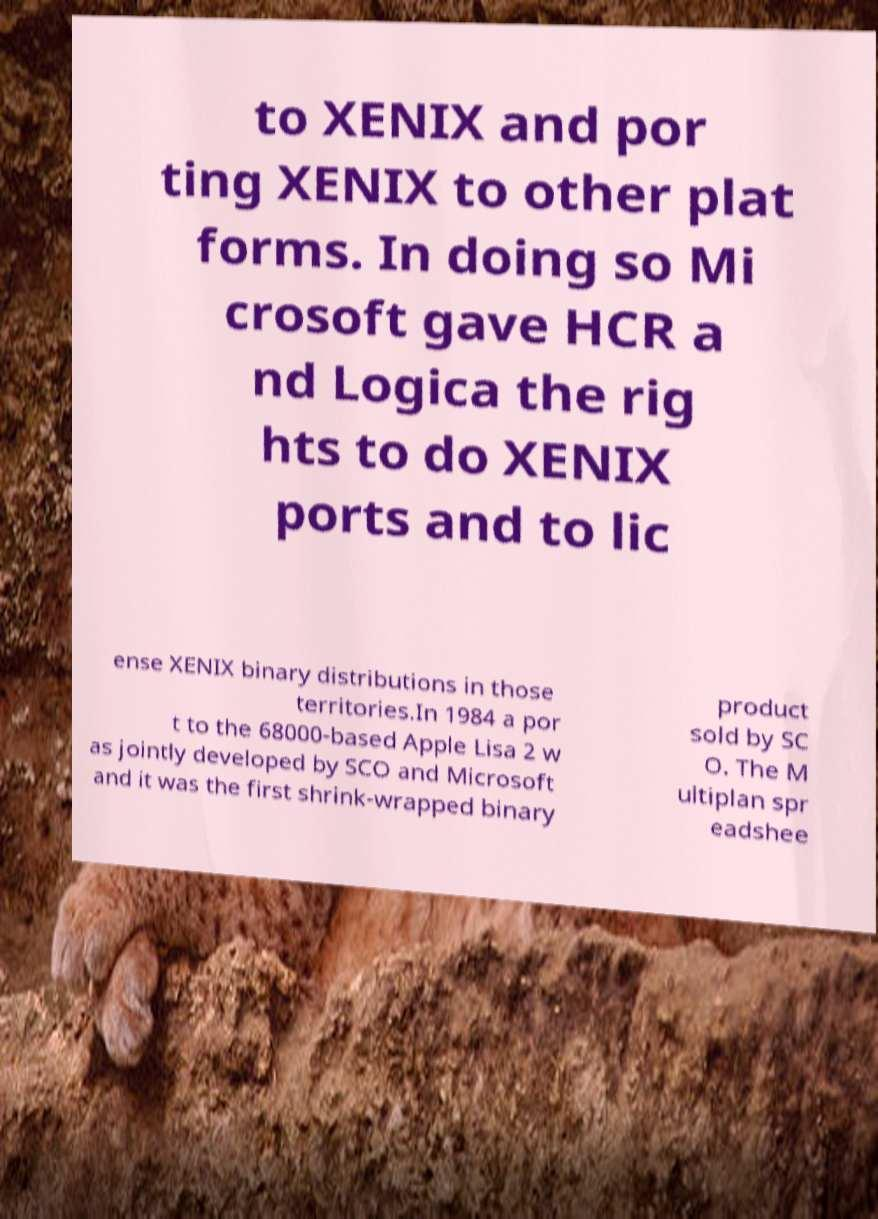I need the written content from this picture converted into text. Can you do that? to XENIX and por ting XENIX to other plat forms. In doing so Mi crosoft gave HCR a nd Logica the rig hts to do XENIX ports and to lic ense XENIX binary distributions in those territories.In 1984 a por t to the 68000-based Apple Lisa 2 w as jointly developed by SCO and Microsoft and it was the first shrink-wrapped binary product sold by SC O. The M ultiplan spr eadshee 